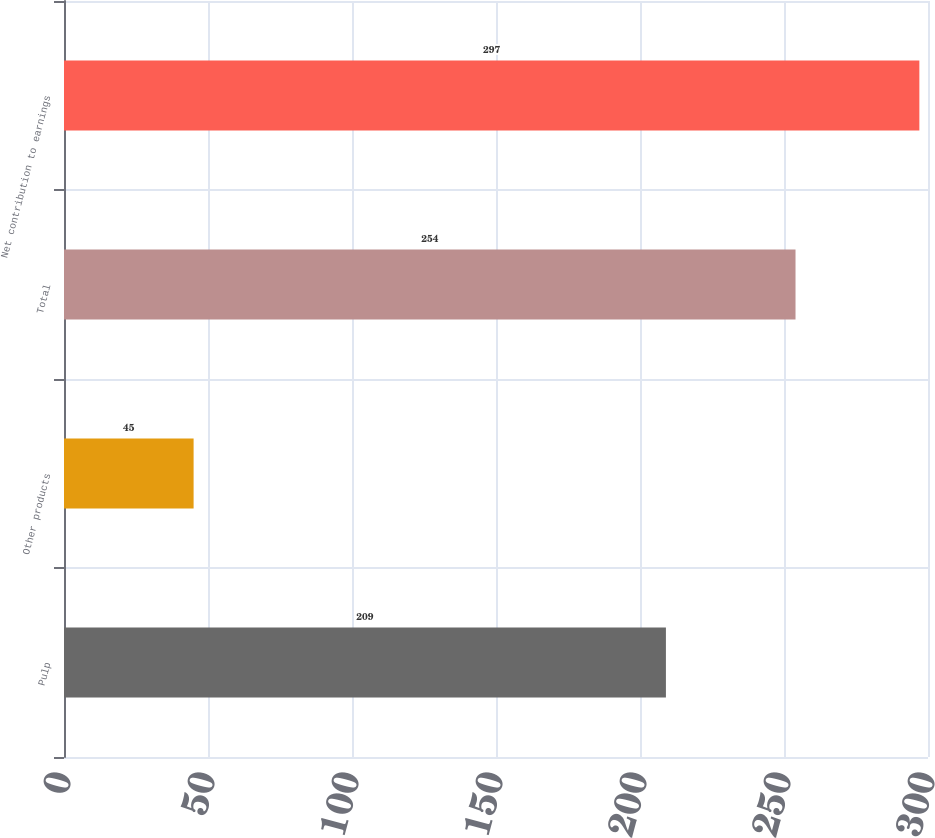Convert chart. <chart><loc_0><loc_0><loc_500><loc_500><bar_chart><fcel>Pulp<fcel>Other products<fcel>Total<fcel>Net contribution to earnings<nl><fcel>209<fcel>45<fcel>254<fcel>297<nl></chart> 